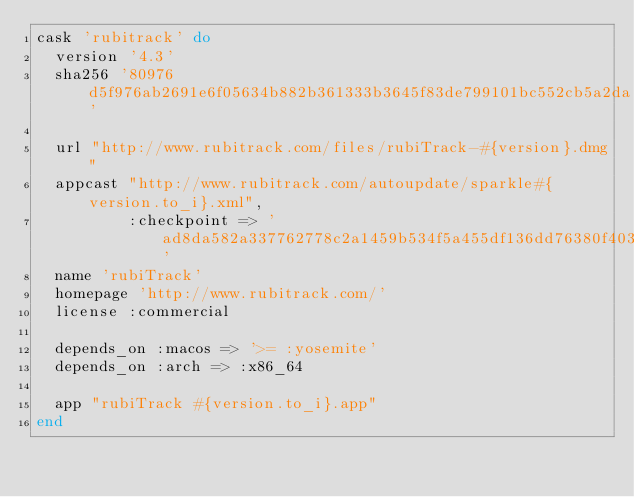Convert code to text. <code><loc_0><loc_0><loc_500><loc_500><_Ruby_>cask 'rubitrack' do
  version '4.3'
  sha256 '80976d5f976ab2691e6f05634b882b361333b3645f83de799101bc552cb5a2da'

  url "http://www.rubitrack.com/files/rubiTrack-#{version}.dmg"
  appcast "http://www.rubitrack.com/autoupdate/sparkle#{version.to_i}.xml",
          :checkpoint => 'ad8da582a337762778c2a1459b534f5a455df136dd76380f403cc52c364c9fc3'
  name 'rubiTrack'
  homepage 'http://www.rubitrack.com/'
  license :commercial

  depends_on :macos => '>= :yosemite'
  depends_on :arch => :x86_64

  app "rubiTrack #{version.to_i}.app"
end
</code> 